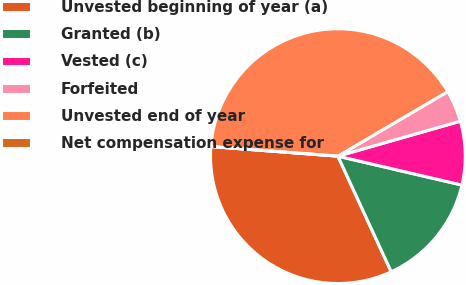Convert chart. <chart><loc_0><loc_0><loc_500><loc_500><pie_chart><fcel>Unvested beginning of year (a)<fcel>Granted (b)<fcel>Vested (c)<fcel>Forfeited<fcel>Unvested end of year<fcel>Net compensation expense for<nl><fcel>33.08%<fcel>14.48%<fcel>8.07%<fcel>4.03%<fcel>40.34%<fcel>0.0%<nl></chart> 